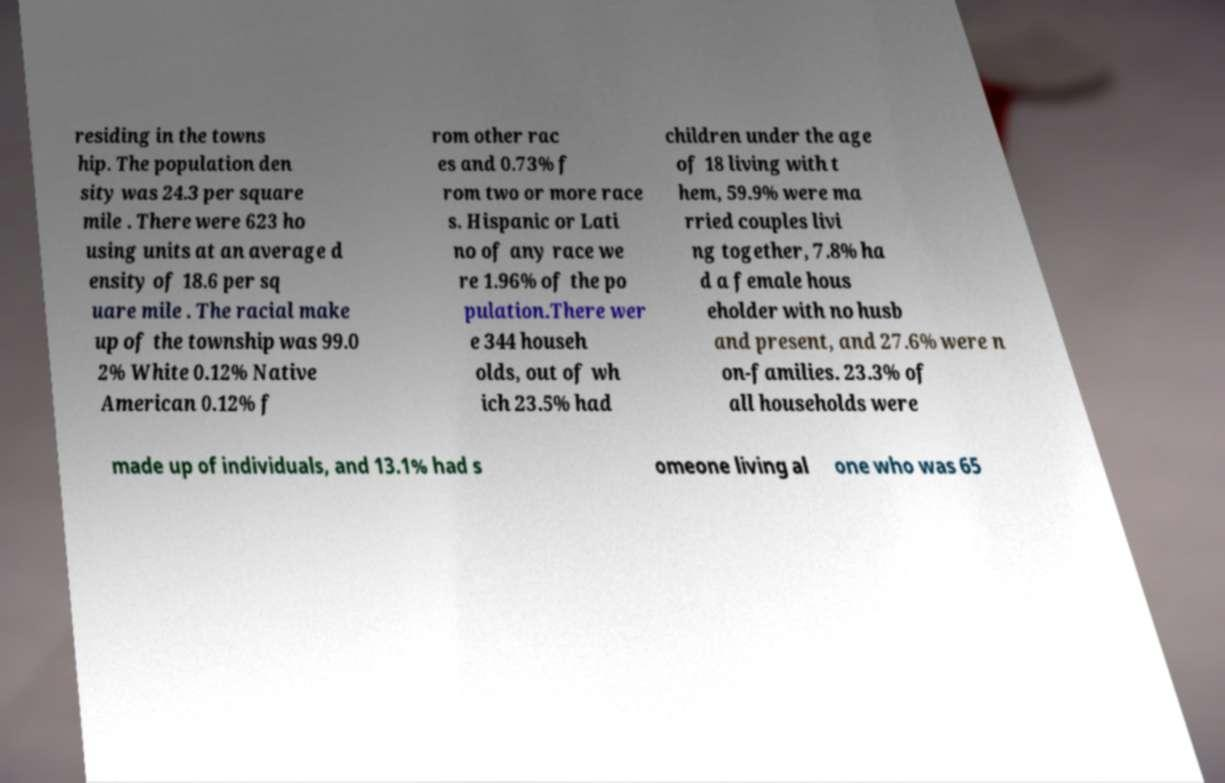Please read and relay the text visible in this image. What does it say? residing in the towns hip. The population den sity was 24.3 per square mile . There were 623 ho using units at an average d ensity of 18.6 per sq uare mile . The racial make up of the township was 99.0 2% White 0.12% Native American 0.12% f rom other rac es and 0.73% f rom two or more race s. Hispanic or Lati no of any race we re 1.96% of the po pulation.There wer e 344 househ olds, out of wh ich 23.5% had children under the age of 18 living with t hem, 59.9% were ma rried couples livi ng together, 7.8% ha d a female hous eholder with no husb and present, and 27.6% were n on-families. 23.3% of all households were made up of individuals, and 13.1% had s omeone living al one who was 65 